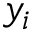<formula> <loc_0><loc_0><loc_500><loc_500>y _ { i }</formula> 